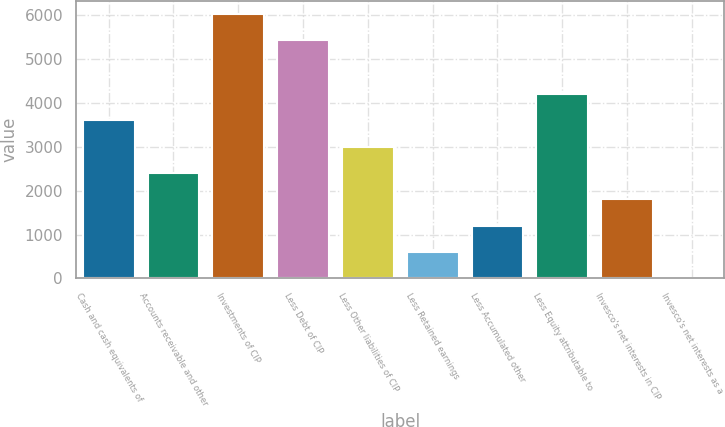<chart> <loc_0><loc_0><loc_500><loc_500><bar_chart><fcel>Cash and cash equivalents of<fcel>Accounts receivable and other<fcel>Investments of CIP<fcel>Less Debt of CIP<fcel>Less Other liabilities of CIP<fcel>Less Retained earnings<fcel>Less Accumulated other<fcel>Less Equity attributable to<fcel>Invesco's net interests in CIP<fcel>Invesco's net interests as a<nl><fcel>3610.14<fcel>2407.16<fcel>6038.49<fcel>5437<fcel>3008.65<fcel>602.69<fcel>1204.18<fcel>4211.63<fcel>1805.67<fcel>1.2<nl></chart> 